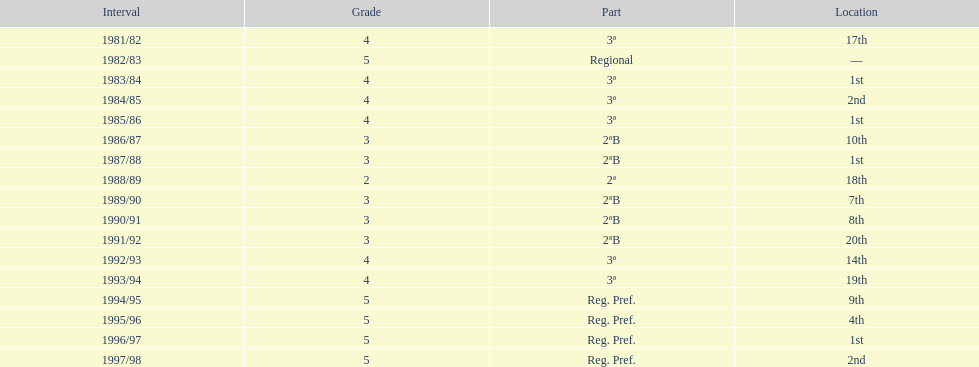How many times was the second place achieved? 2. 